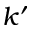<formula> <loc_0><loc_0><loc_500><loc_500>k ^ { \prime }</formula> 